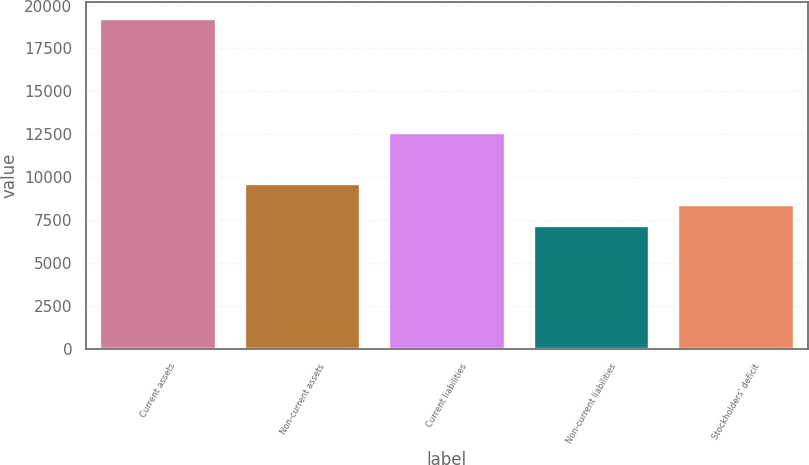Convert chart. <chart><loc_0><loc_0><loc_500><loc_500><bar_chart><fcel>Current assets<fcel>Non-current assets<fcel>Current liabilities<fcel>Non-current liabilities<fcel>Stockholders' deficit<nl><fcel>19246<fcel>9589.2<fcel>12579<fcel>7175<fcel>8382.1<nl></chart> 